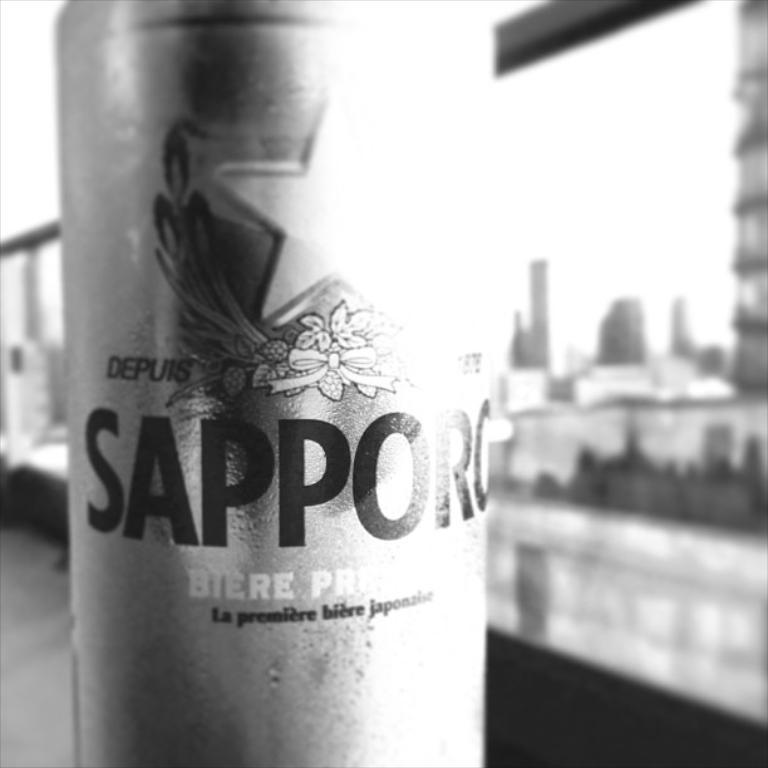Provide a one-sentence caption for the provided image. A can of Sapporo beer in front of buildings. 